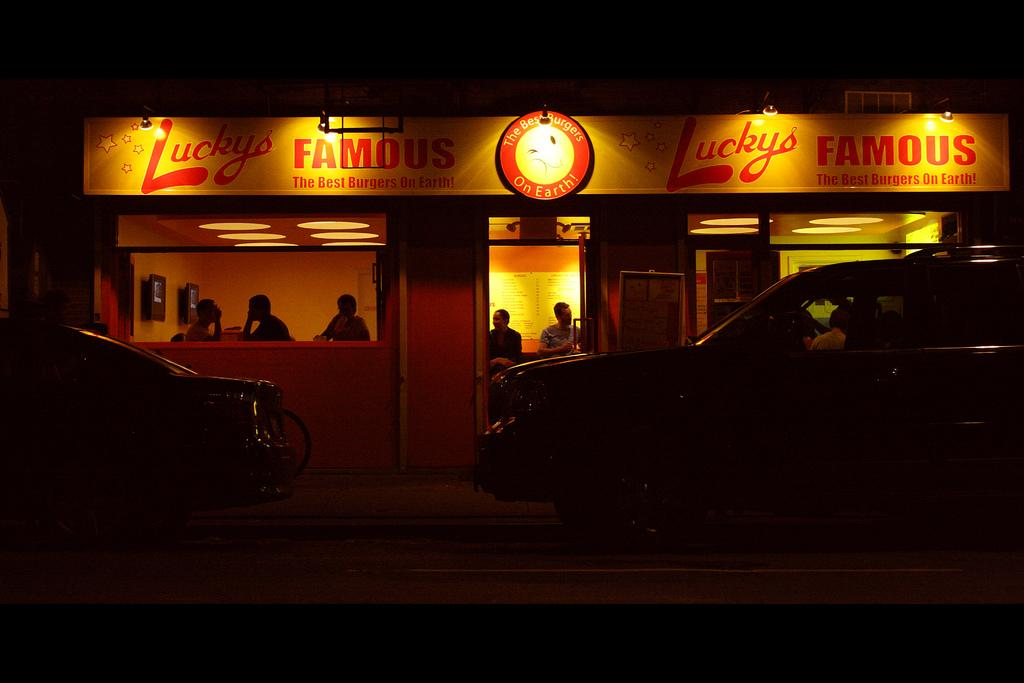What type of establishment is located in the center of the image? There is a restaurant in the center of the image. Can you describe the people inside the restaurant? There are people sitting in the restaurant. What is at the bottom of the image? There is a road at the bottom of the image. What type of vehicles can be seen on the road? Cars are visible on the road. How does the restaurant compare to the sea in the image? There is no sea present in the image, so it cannot be compared to the restaurant. 